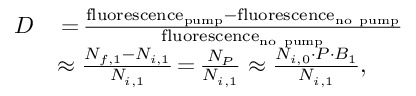<formula> <loc_0><loc_0><loc_500><loc_500>\begin{array} { r l } { D } & { \, { = } \, \frac { f l u o r e s c e n c e _ { p u m p } - f l u o r e s c e n c e _ { n o p u m p } } { f l u o r e s c e n c e _ { n o p u m p } } } \\ & { \approx \frac { N _ { f , 1 } - N _ { i , 1 } } { N _ { i , 1 } } \, { = } \, \frac { N _ { P } } { N _ { i , 1 } } \approx \frac { N _ { i , 0 } \cdot P \cdot B _ { 1 } } { N _ { i , 1 } } , } \end{array}</formula> 